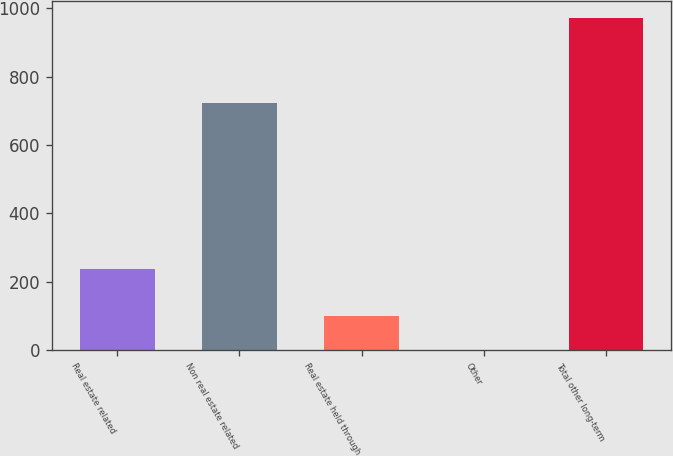Convert chart to OTSL. <chart><loc_0><loc_0><loc_500><loc_500><bar_chart><fcel>Real estate related<fcel>Non real estate related<fcel>Real estate held through<fcel>Other<fcel>Total other long-term<nl><fcel>237<fcel>724<fcel>98.2<fcel>1<fcel>973<nl></chart> 